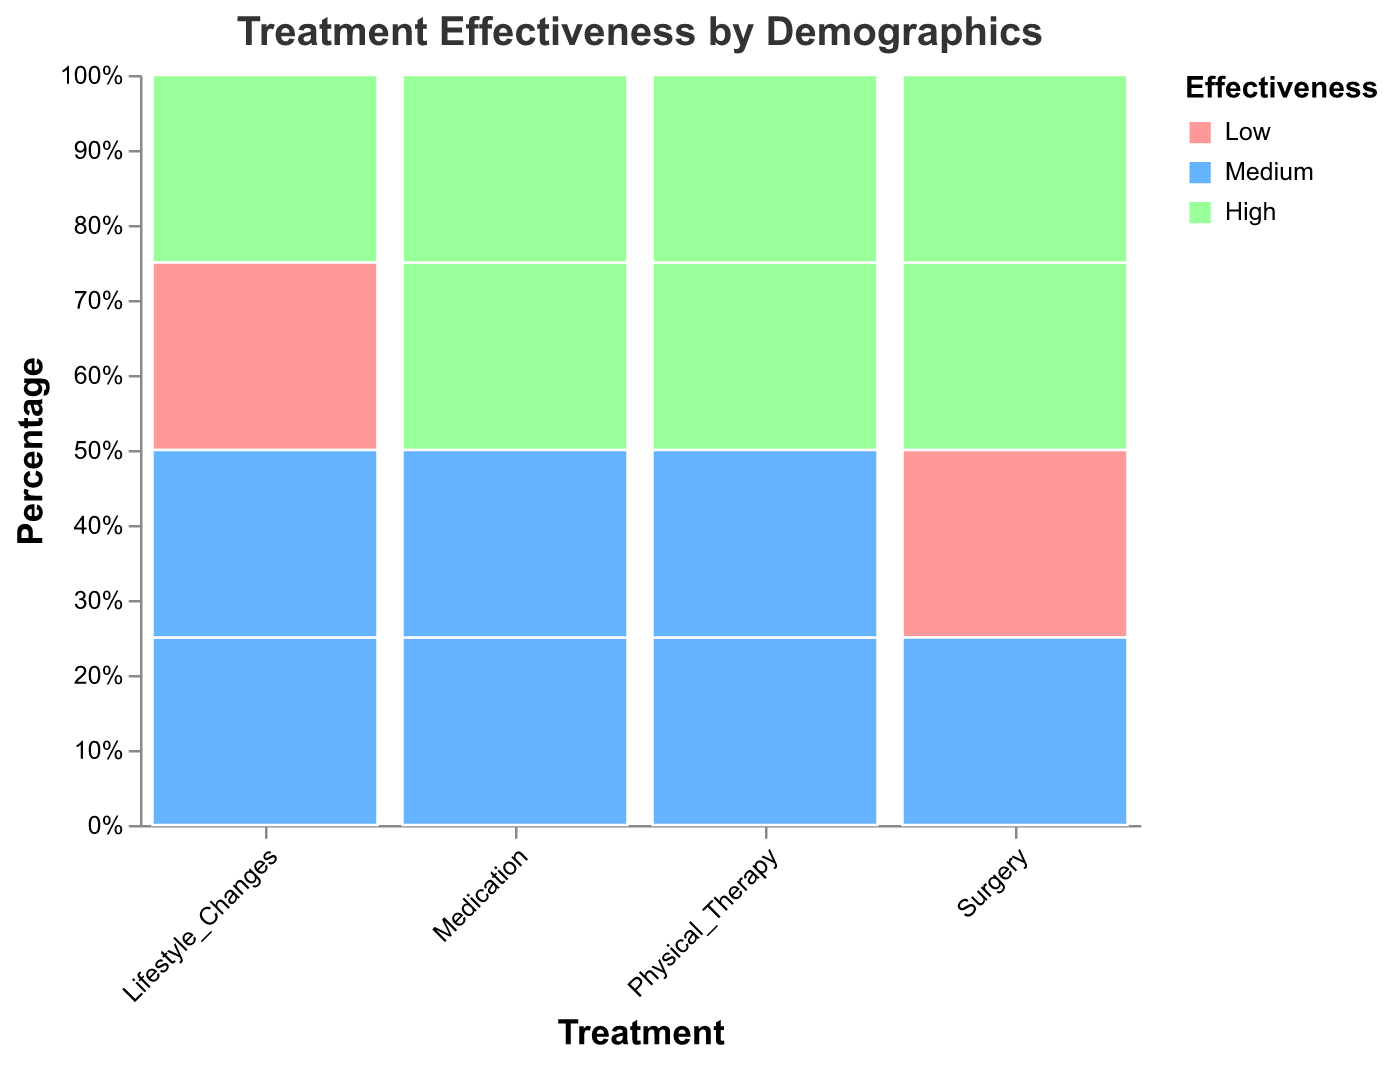What's the title of the plot? The title of the plot is usually located at the top center of the figure.
Answer: Treatment Effectiveness by Demographics What does the color green represent in the plot? Colors in the plot usually correspond to categories in the legend. Find the green color in the legend.
Answer: High Effectiveness In which age group and gender is medication most effective? Look for the tallest green bar under the "Medication" category and check its associated age group and gender in the tooltip or the axis labels.
Answer: Age Group 51-60, Female How many categories of effectiveness are there? The number of distinct colors in the legend represents the different categories of effectiveness.
Answer: Three (Low, Medium, High) What is the overall effectiveness of surgery for males aged 40-50? Find the "Surgery" treatment and identify the section for males aged 40-50. Look for the proportion that corresponds to each effectiveness category using the tooltip.
Answer: High Effectiveness Compare the effectiveness of Physical Therapy for males aged 51-60 and females aged 51-60. Look for the "Physical Therapy" treatment and identify the sections for males and females aged 51-60. Compare the color proportions between both groups in the plot.
Answer: Males have mostly High effectiveness, while females have mostly Medium effectiveness What treatment shows the highest effectiveness for females in the age group 40-50? Look for the "High Effectiveness" color across different treatments in the 40-50 age group for females.
Answer: Physical Therapy Does any treatment have a Low Effectiveness for females aged 51-60? Find the sections for females aged 51-60 in each treatment and check for the presence of the Low Effectiveness color.
Answer: No Which treatment shows a Medium Effectiveness for males aged 40-50? Find the sections under each treatment category for males aged 40-50 and identify those with the Medium Effectiveness color.
Answer: Physical Therapy, Lifestyle Changes Which treatment option has the most varied effectiveness for males aged 40-50? Examine the color proportions under each treatment for males aged 40-50 and identify the treatment with the most even distribution among the effectiveness categories.
Answer: Lifestyle Changes 